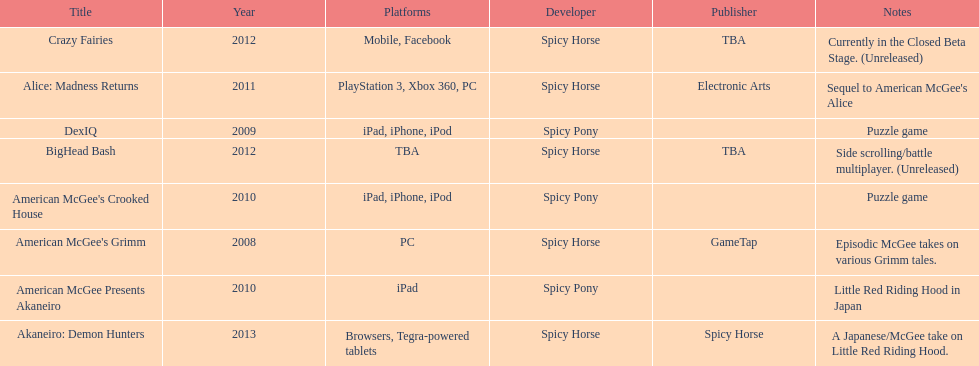Spicy pony released a total of three games; their game, "american mcgee's crooked house" was released on which platforms? Ipad, iphone, ipod. 